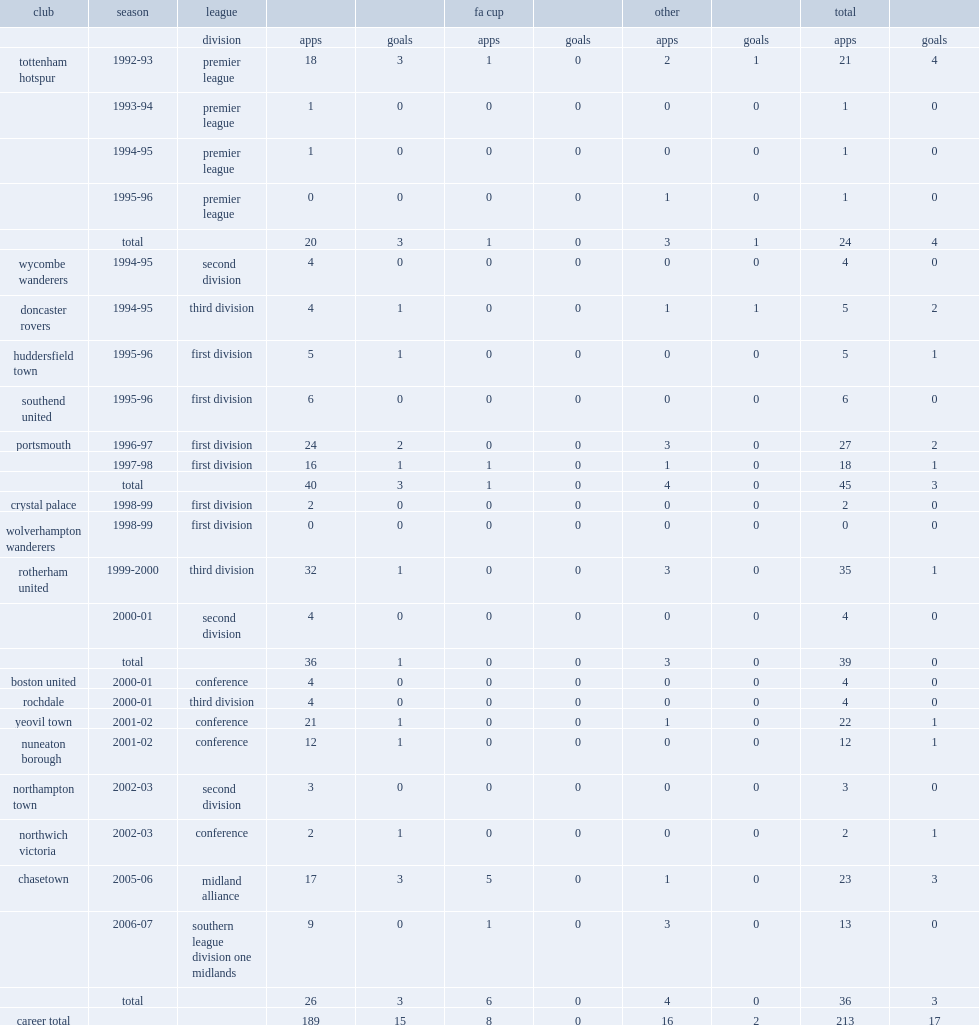How many goals did andy turner score for chasetown during the 2005-06 season, in midland alliance? 3.0. 